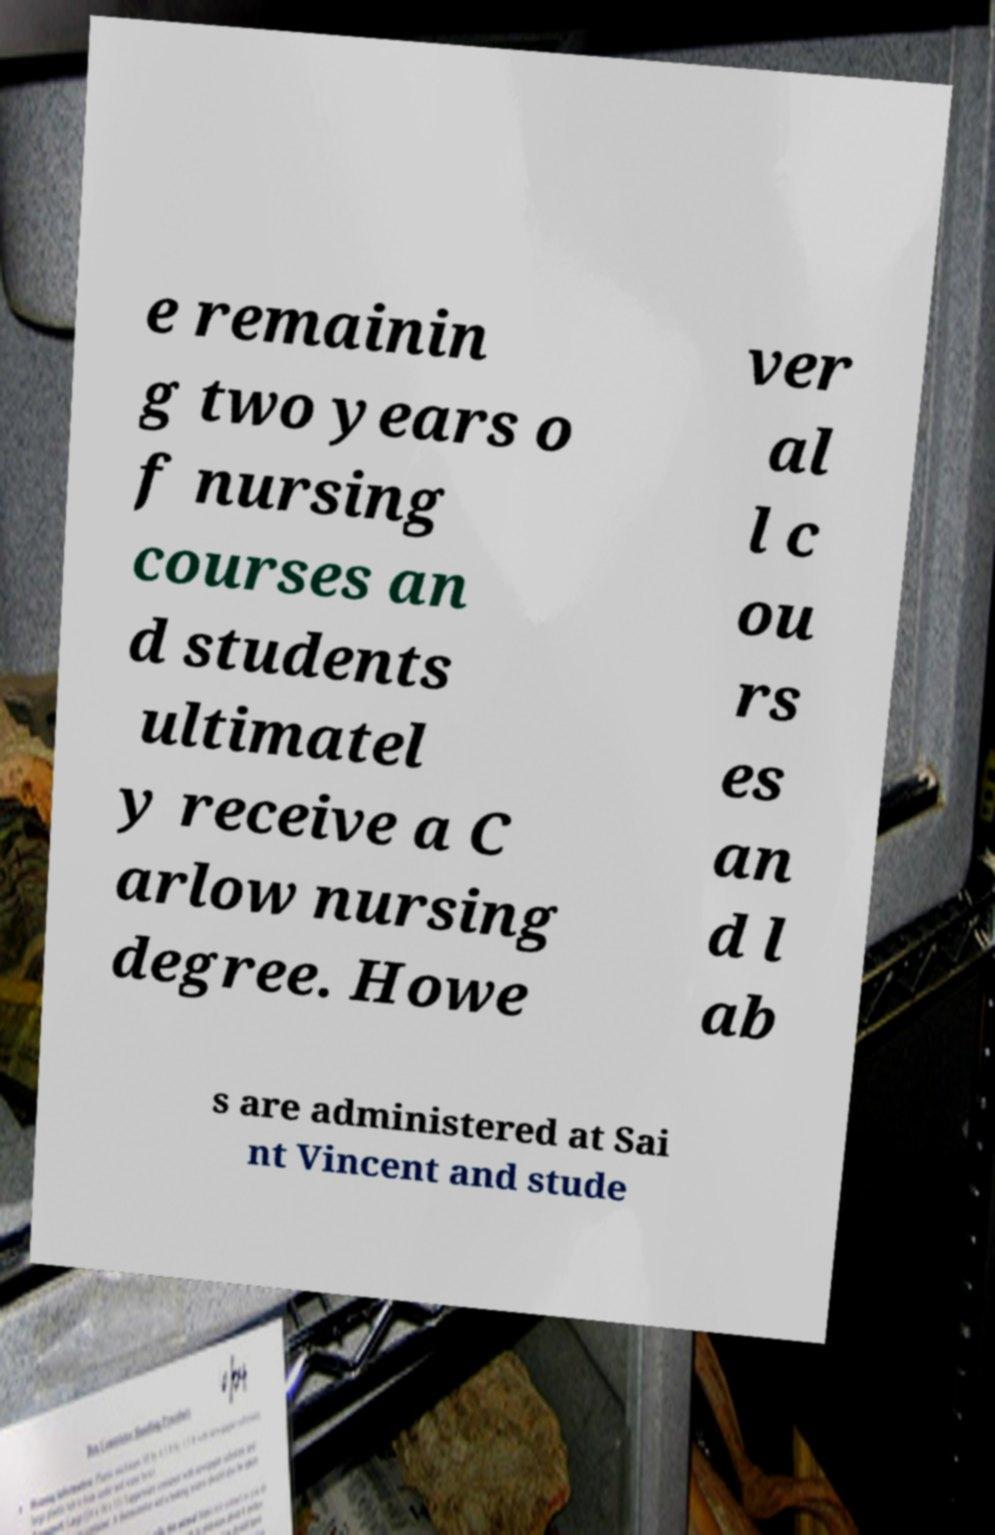Could you assist in decoding the text presented in this image and type it out clearly? e remainin g two years o f nursing courses an d students ultimatel y receive a C arlow nursing degree. Howe ver al l c ou rs es an d l ab s are administered at Sai nt Vincent and stude 